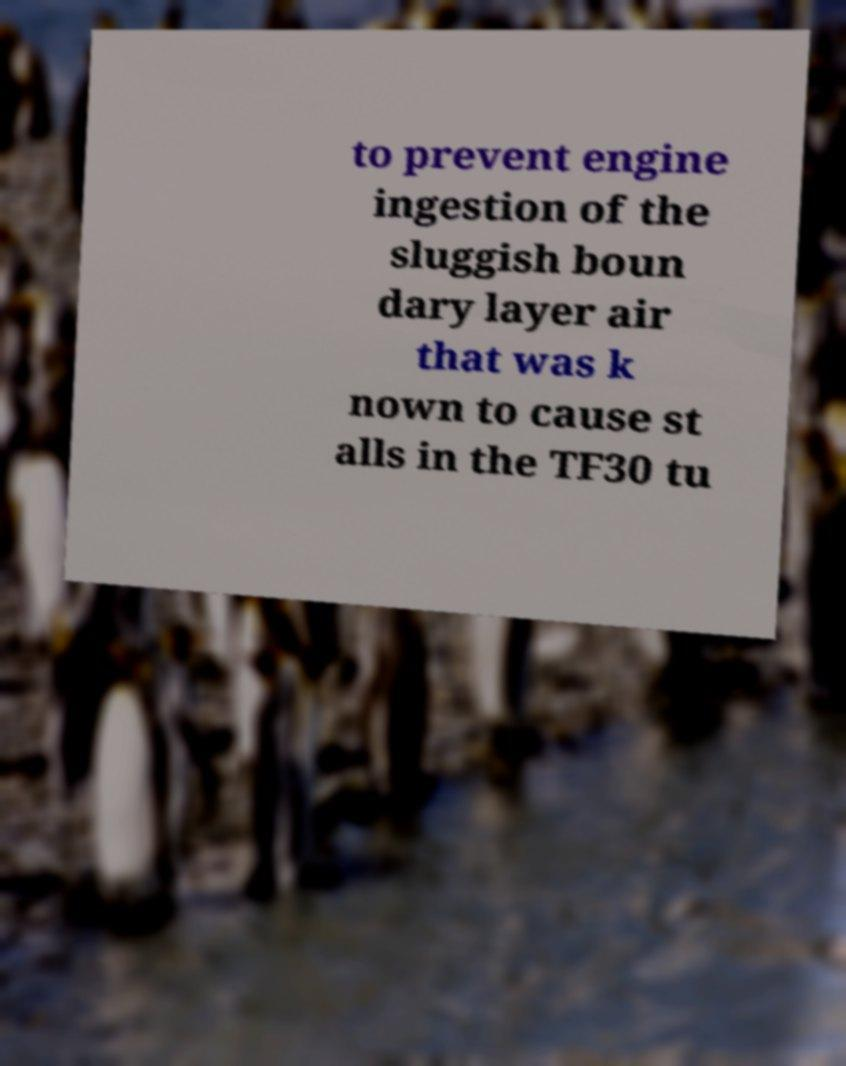I need the written content from this picture converted into text. Can you do that? to prevent engine ingestion of the sluggish boun dary layer air that was k nown to cause st alls in the TF30 tu 